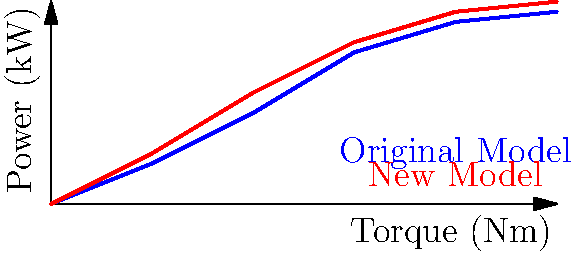As a sales executive, you're presenting the performance curves of a new engine model compared to the original. The graph shows power output (kW) against torque (Nm) for both models. At what torque value does the new model (red curve) show the most significant improvement in power output compared to the original model (blue curve)? To determine the torque value where the new model shows the most significant improvement:

1. Analyze the two curves: blue for the original model, red for the new model.
2. Look for the point where the vertical distance between the curves is greatest.
3. This occurs around 200 Nm of torque.
4. At 200 Nm:
   - Original model (blue) produces about 90 kW
   - New model (red) produces about 110 kW
5. The difference here (20 kW) is the largest gap between the curves.
6. Before and after this point, the curves are closer together, indicating less improvement.

Therefore, the most significant improvement in power output for the new model compared to the original occurs at approximately 200 Nm of torque.
Answer: 200 Nm 